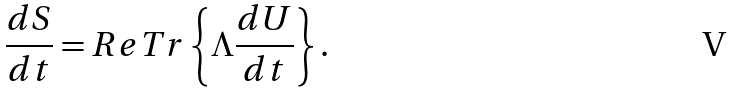Convert formula to latex. <formula><loc_0><loc_0><loc_500><loc_500>\frac { d S } { d t } = R e T r \left \{ \Lambda \frac { d U } { d t } \right \} .</formula> 